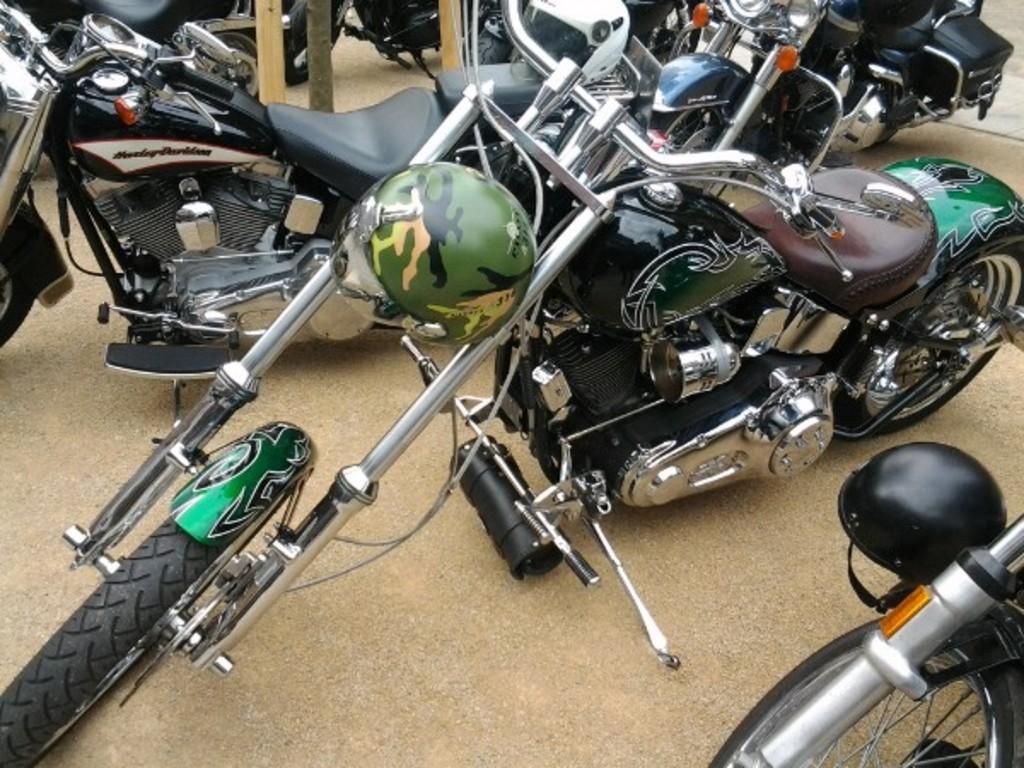How would you summarize this image in a sentence or two? In this image we can see a group of motorcycles parked on the ground. On the right side of the image we can see a helmet. At the top of the image we can see some wooden poles. 